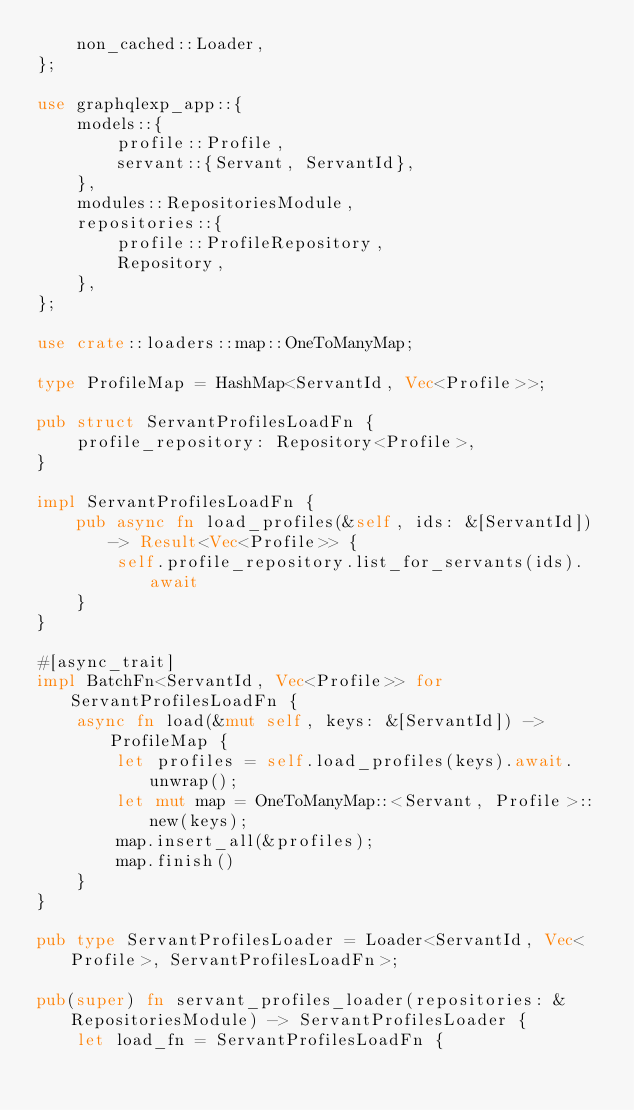<code> <loc_0><loc_0><loc_500><loc_500><_Rust_>    non_cached::Loader,
};

use graphqlexp_app::{
    models::{
        profile::Profile,
        servant::{Servant, ServantId},
    },
    modules::RepositoriesModule,
    repositories::{
        profile::ProfileRepository,
        Repository,
    },
};

use crate::loaders::map::OneToManyMap;

type ProfileMap = HashMap<ServantId, Vec<Profile>>;

pub struct ServantProfilesLoadFn {
    profile_repository: Repository<Profile>,
}

impl ServantProfilesLoadFn {
    pub async fn load_profiles(&self, ids: &[ServantId]) -> Result<Vec<Profile>> {
        self.profile_repository.list_for_servants(ids).await
    }
}

#[async_trait]
impl BatchFn<ServantId, Vec<Profile>> for ServantProfilesLoadFn {
    async fn load(&mut self, keys: &[ServantId]) -> ProfileMap {
        let profiles = self.load_profiles(keys).await.unwrap();
        let mut map = OneToManyMap::<Servant, Profile>::new(keys);
        map.insert_all(&profiles);
        map.finish()
    }
}

pub type ServantProfilesLoader = Loader<ServantId, Vec<Profile>, ServantProfilesLoadFn>;

pub(super) fn servant_profiles_loader(repositories: &RepositoriesModule) -> ServantProfilesLoader {
    let load_fn = ServantProfilesLoadFn {</code> 